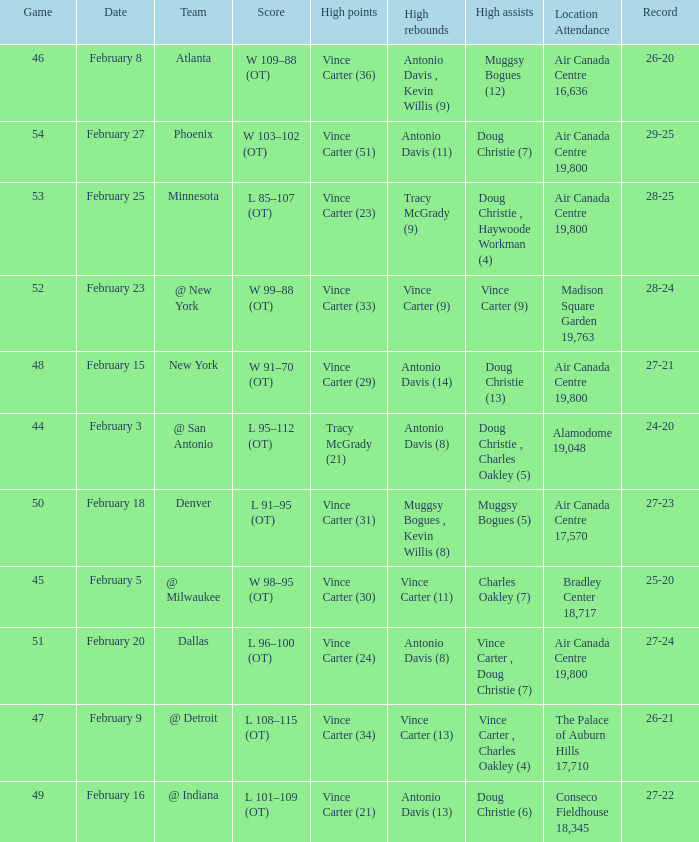How many games were played when the record was 26-21? 1.0. 